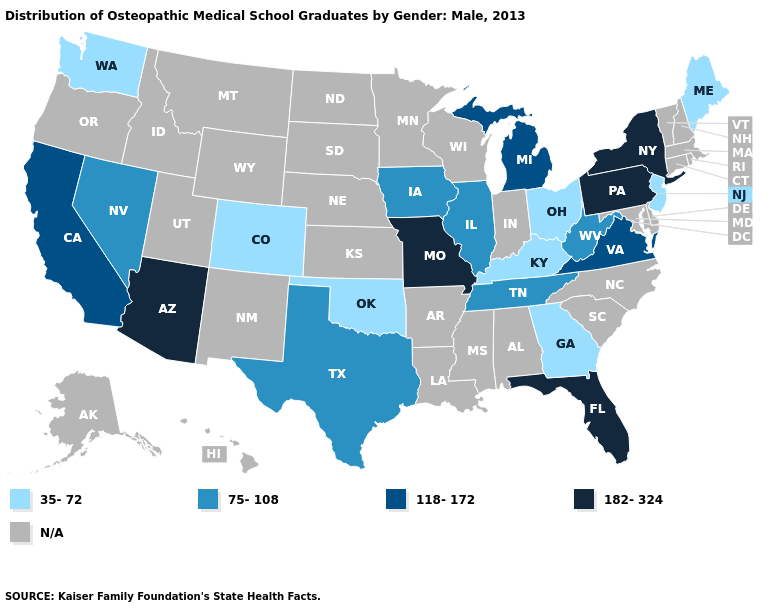What is the lowest value in the USA?
Quick response, please. 35-72. Among the states that border New York , which have the lowest value?
Quick response, please. New Jersey. Is the legend a continuous bar?
Give a very brief answer. No. Among the states that border Georgia , does Florida have the lowest value?
Concise answer only. No. Name the states that have a value in the range 182-324?
Quick response, please. Arizona, Florida, Missouri, New York, Pennsylvania. What is the lowest value in the USA?
Quick response, please. 35-72. Name the states that have a value in the range 182-324?
Give a very brief answer. Arizona, Florida, Missouri, New York, Pennsylvania. What is the highest value in the USA?
Write a very short answer. 182-324. What is the value of South Carolina?
Give a very brief answer. N/A. Is the legend a continuous bar?
Write a very short answer. No. What is the value of Arizona?
Quick response, please. 182-324. What is the value of Tennessee?
Concise answer only. 75-108. What is the lowest value in the West?
Concise answer only. 35-72. Which states hav the highest value in the MidWest?
Give a very brief answer. Missouri. What is the highest value in states that border Mississippi?
Keep it brief. 75-108. 